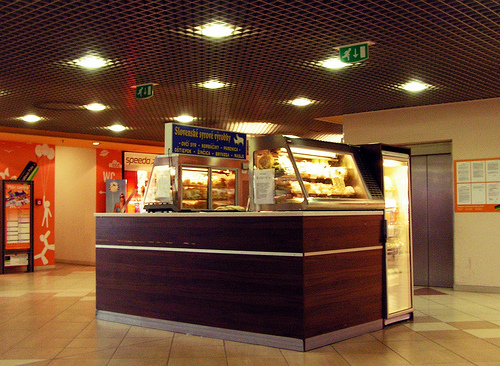<image>
Can you confirm if the light is under the roof? Yes. The light is positioned underneath the roof, with the roof above it in the vertical space. 